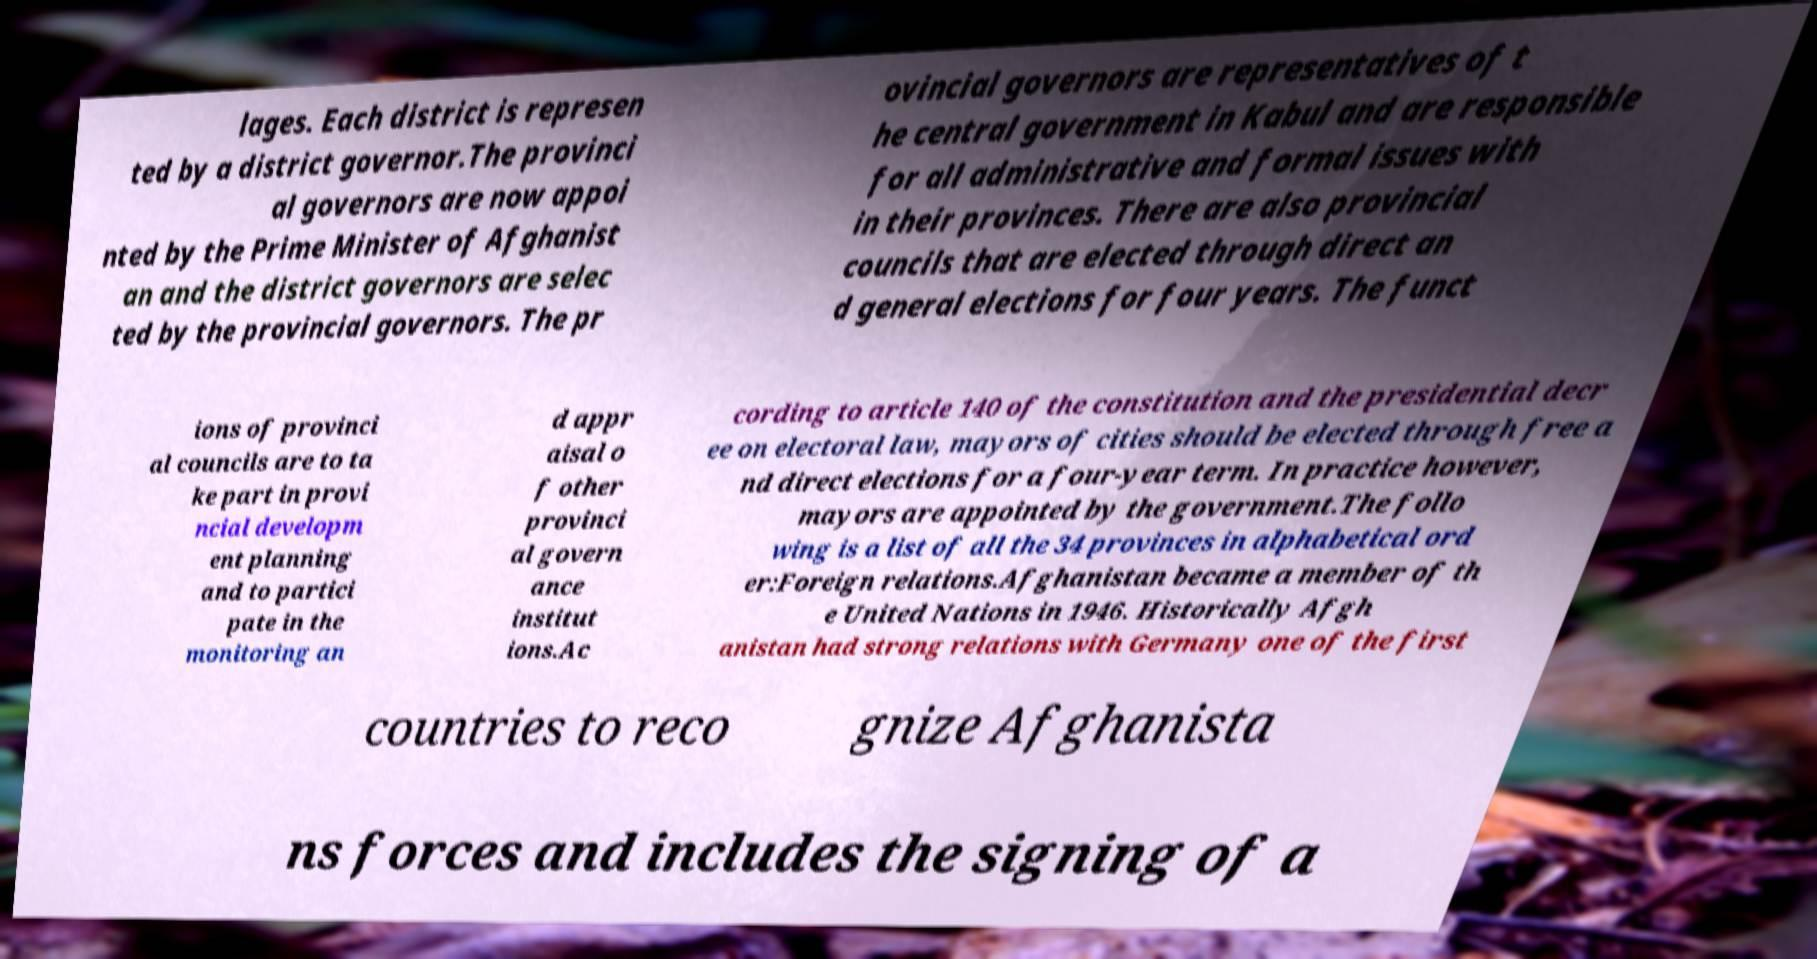What messages or text are displayed in this image? I need them in a readable, typed format. lages. Each district is represen ted by a district governor.The provinci al governors are now appoi nted by the Prime Minister of Afghanist an and the district governors are selec ted by the provincial governors. The pr ovincial governors are representatives of t he central government in Kabul and are responsible for all administrative and formal issues with in their provinces. There are also provincial councils that are elected through direct an d general elections for four years. The funct ions of provinci al councils are to ta ke part in provi ncial developm ent planning and to partici pate in the monitoring an d appr aisal o f other provinci al govern ance institut ions.Ac cording to article 140 of the constitution and the presidential decr ee on electoral law, mayors of cities should be elected through free a nd direct elections for a four-year term. In practice however, mayors are appointed by the government.The follo wing is a list of all the 34 provinces in alphabetical ord er:Foreign relations.Afghanistan became a member of th e United Nations in 1946. Historically Afgh anistan had strong relations with Germany one of the first countries to reco gnize Afghanista ns forces and includes the signing of a 